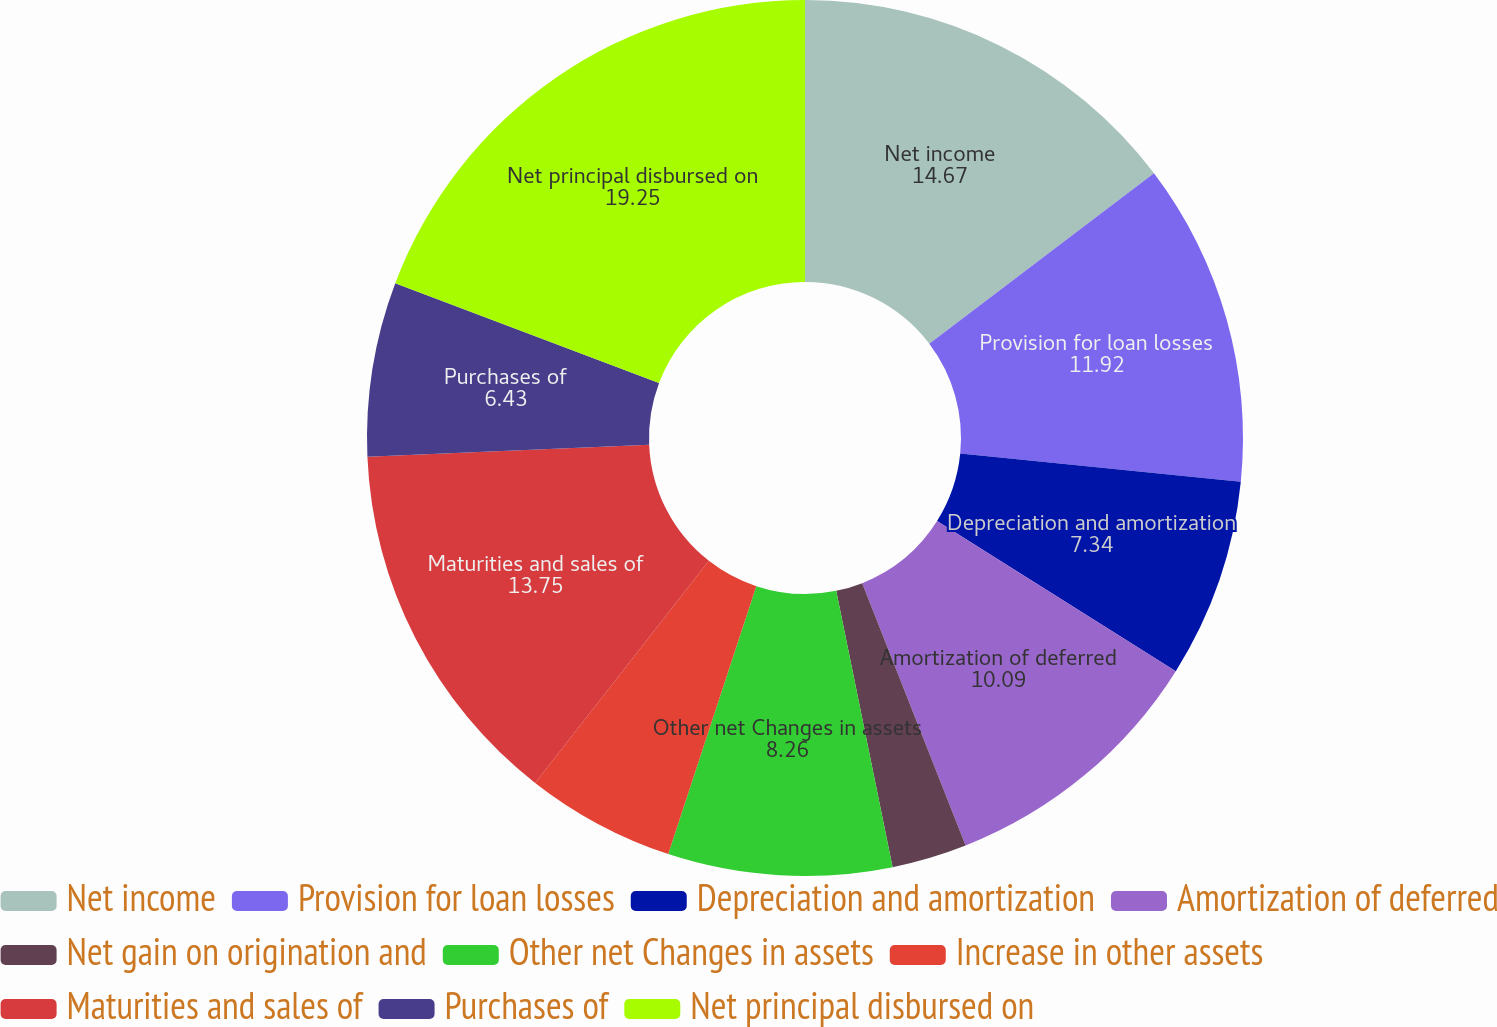Convert chart to OTSL. <chart><loc_0><loc_0><loc_500><loc_500><pie_chart><fcel>Net income<fcel>Provision for loan losses<fcel>Depreciation and amortization<fcel>Amortization of deferred<fcel>Net gain on origination and<fcel>Other net Changes in assets<fcel>Increase in other assets<fcel>Maturities and sales of<fcel>Purchases of<fcel>Net principal disbursed on<nl><fcel>14.67%<fcel>11.92%<fcel>7.34%<fcel>10.09%<fcel>2.77%<fcel>8.26%<fcel>5.51%<fcel>13.75%<fcel>6.43%<fcel>19.25%<nl></chart> 